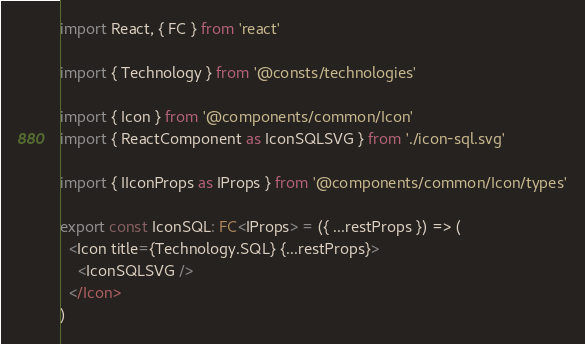<code> <loc_0><loc_0><loc_500><loc_500><_TypeScript_>import React, { FC } from 'react'

import { Technology } from '@consts/technologies'

import { Icon } from '@components/common/Icon'
import { ReactComponent as IconSQLSVG } from './icon-sql.svg'

import { IIconProps as IProps } from '@components/common/Icon/types'

export const IconSQL: FC<IProps> = ({ ...restProps }) => (
  <Icon title={Technology.SQL} {...restProps}>
    <IconSQLSVG />
  </Icon>
)
</code> 